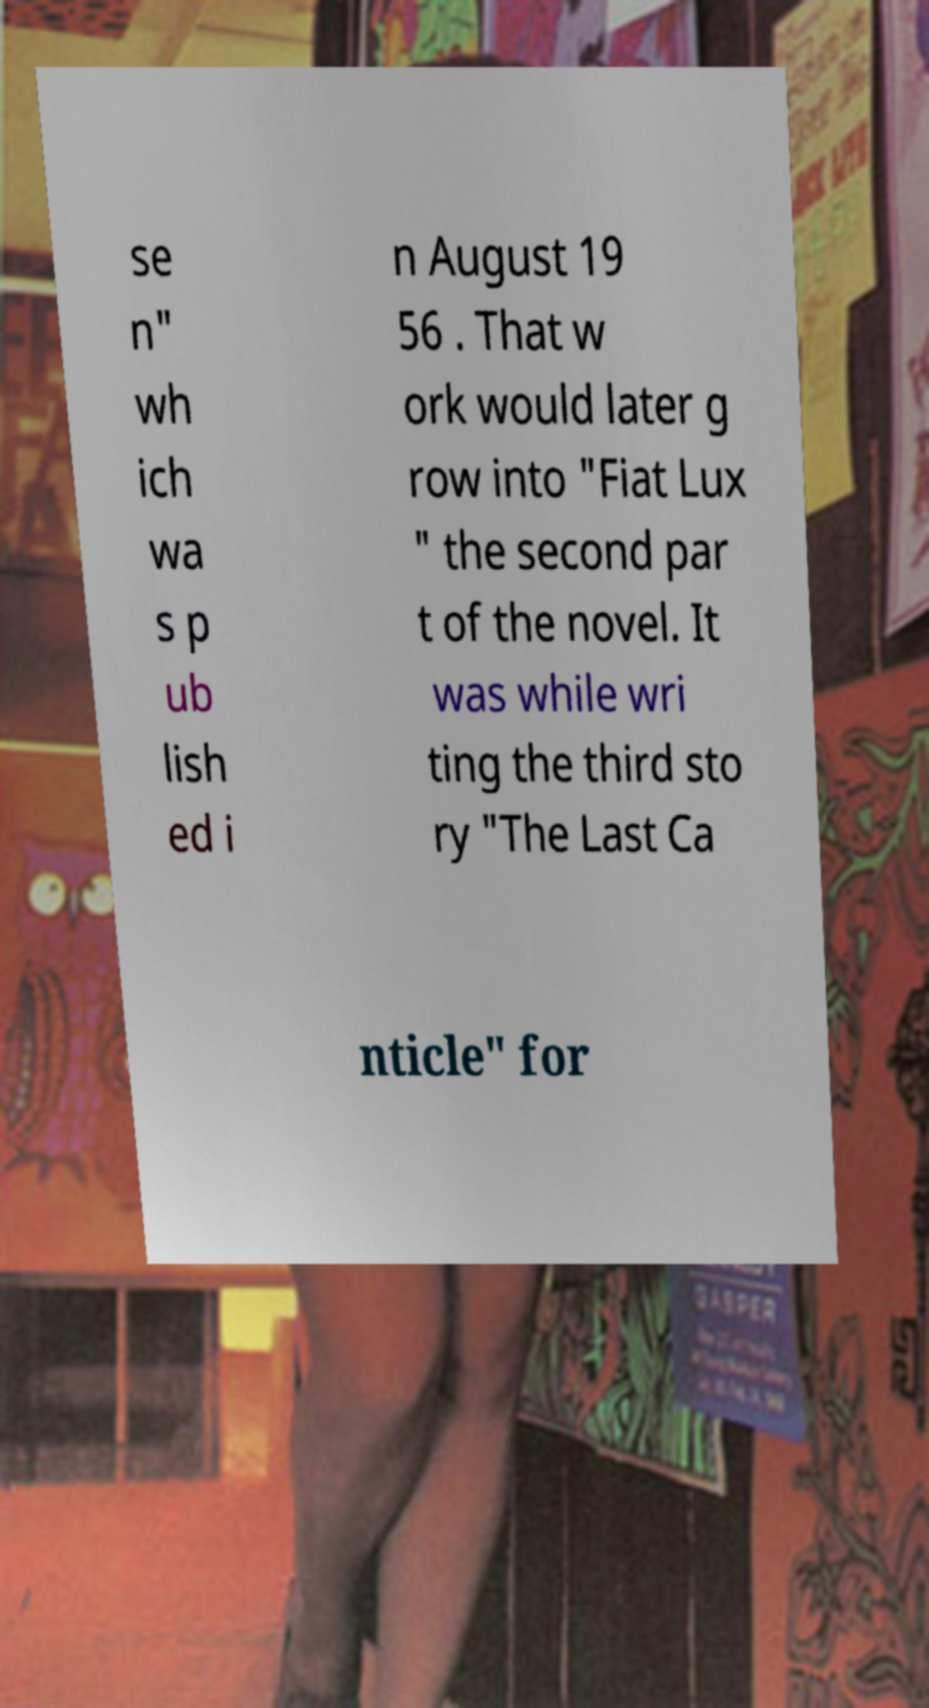Can you accurately transcribe the text from the provided image for me? se n" wh ich wa s p ub lish ed i n August 19 56 . That w ork would later g row into "Fiat Lux " the second par t of the novel. It was while wri ting the third sto ry "The Last Ca nticle" for 